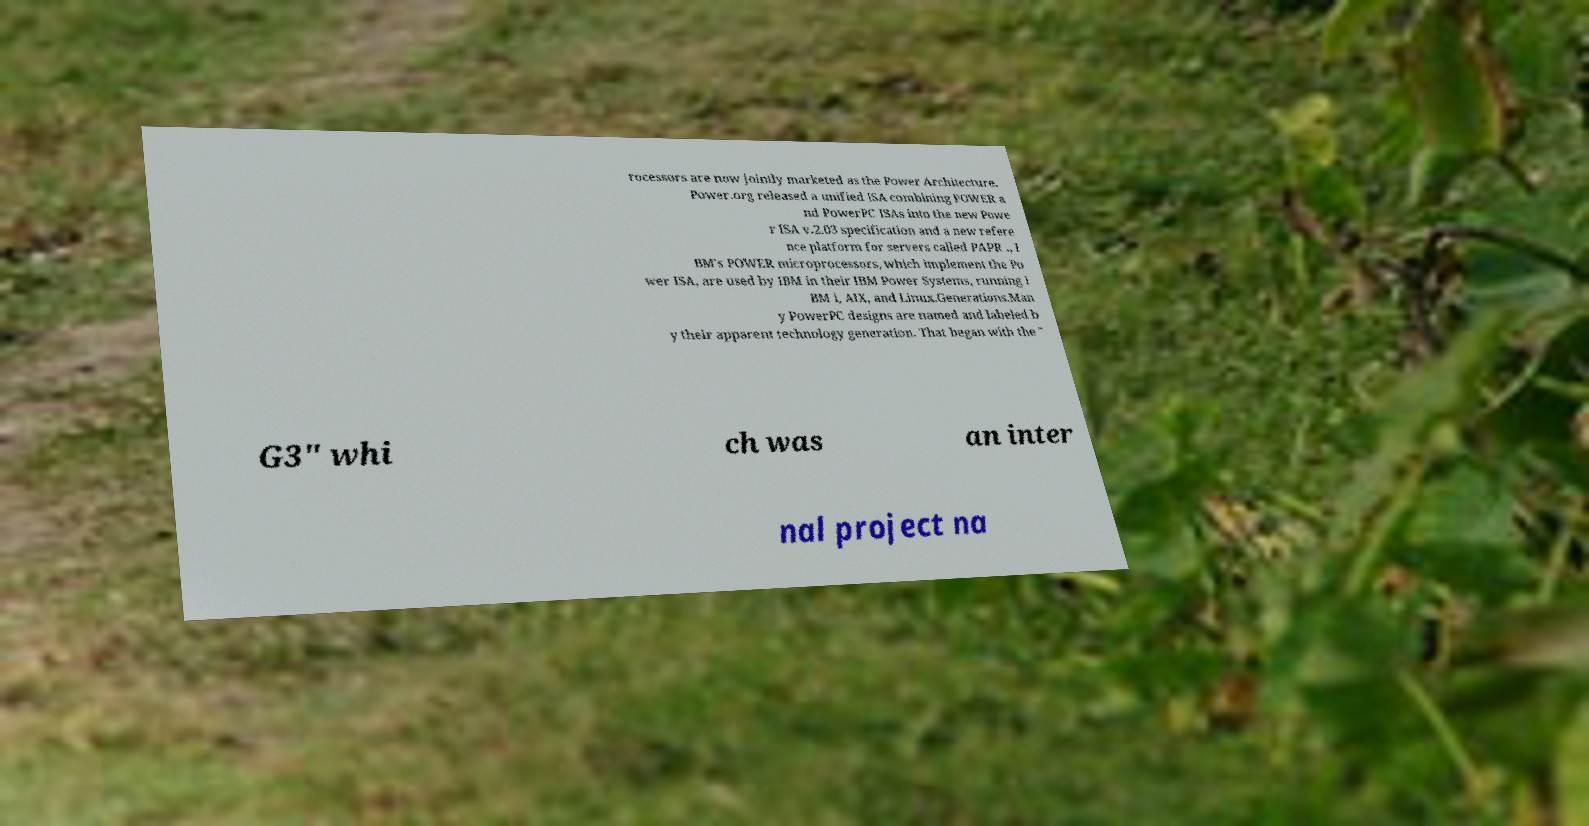Can you accurately transcribe the text from the provided image for me? rocessors are now jointly marketed as the Power Architecture. Power.org released a unified ISA combining POWER a nd PowerPC ISAs into the new Powe r ISA v.2.03 specification and a new refere nce platform for servers called PAPR ., I BM's POWER microprocessors, which implement the Po wer ISA, are used by IBM in their IBM Power Systems, running I BM i, AIX, and Linux.Generations.Man y PowerPC designs are named and labeled b y their apparent technology generation. That began with the " G3" whi ch was an inter nal project na 